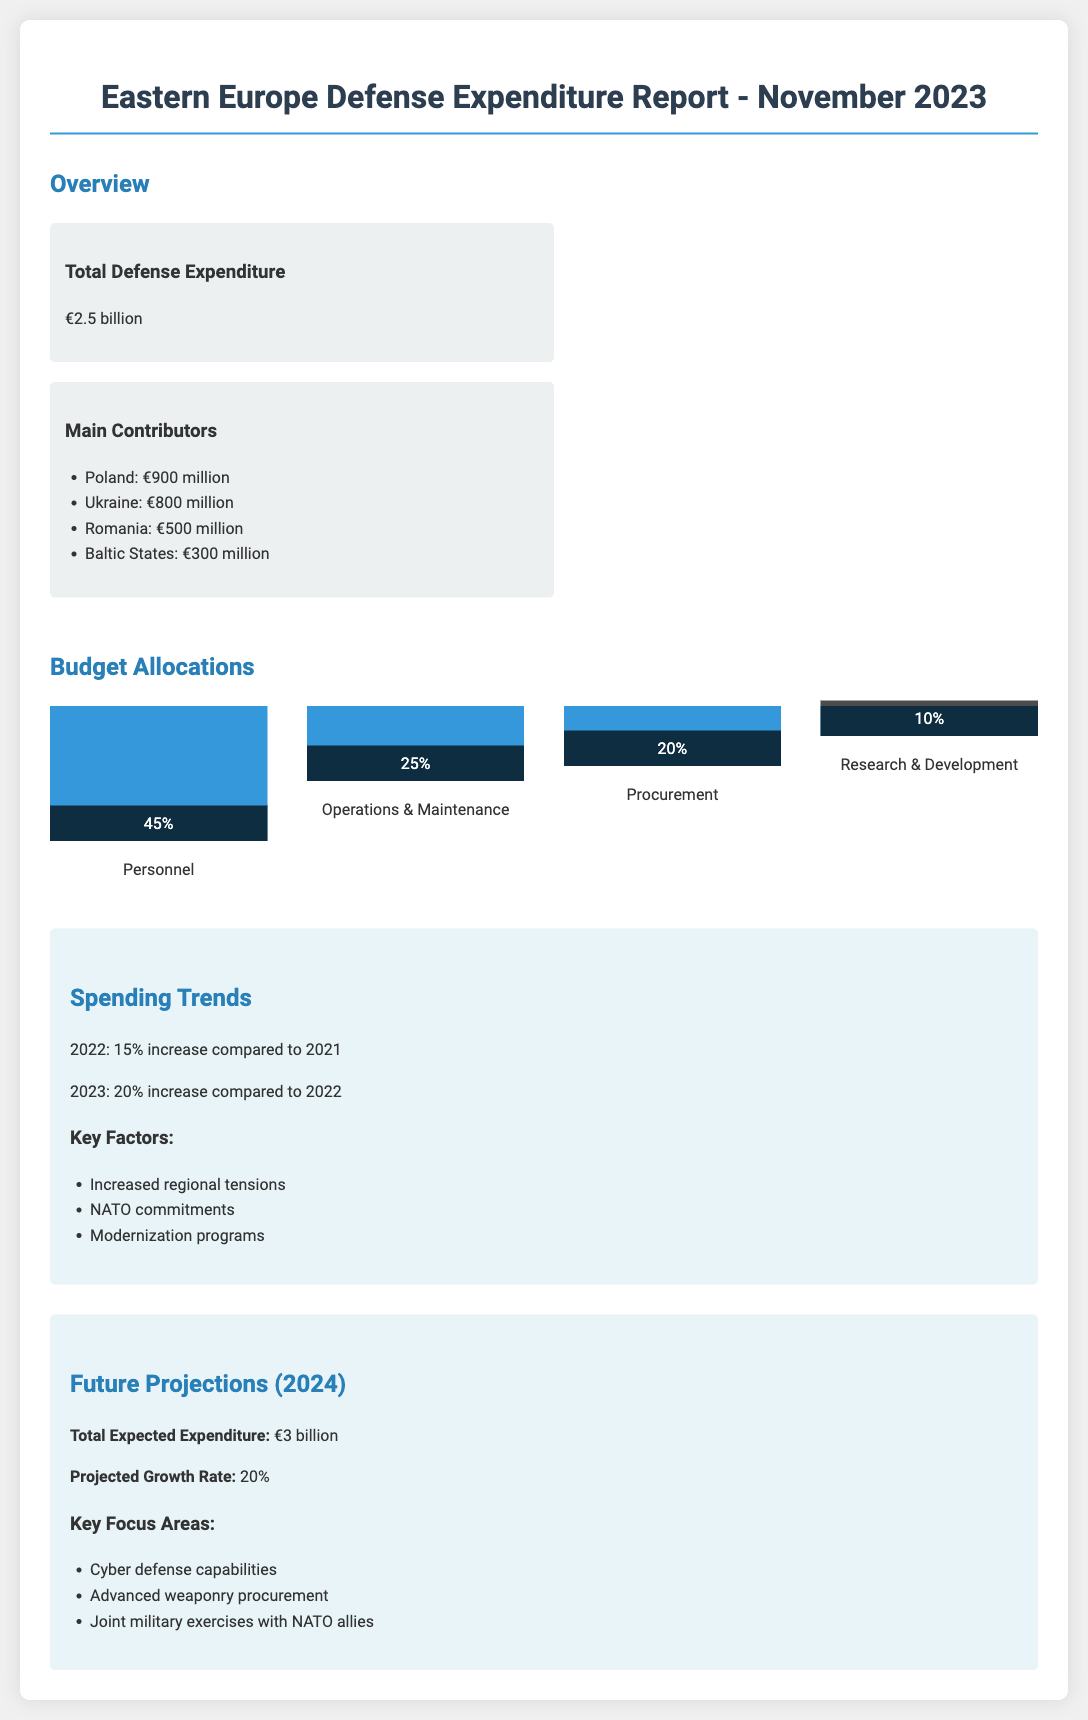What is the total defense expenditure? The total defense expenditure is presented in the overview section and is stated as €2.5 billion.
Answer: €2.5 billion Who are the main contributors to the defense expenditure? The main contributors listed in the document include Poland, Ukraine, Romania, and the Baltic States, with their respective amounts provided.
Answer: Poland, Ukraine, Romania, Baltic States What percentage of the budget is allocated to personnel? The budget allocation section shows that personnel accounts for 45% of the total budget.
Answer: 45% What is the projected total expected expenditure for 2024? The future projections indicate that the total expected expenditure for 2024 is €3 billion.
Answer: €3 billion What increase in defense expenditure was observed in 2022 compared to 2021? The spending trends show that there was a 15% increase in defense expenditure in 2022 compared to the previous year.
Answer: 15% What are the key focus areas for future defense spending? The key focus areas for 2024 are listed in the projections section, including cyber defense capabilities and advanced weaponry procurement.
Answer: Cyber defense capabilities, advanced weaponry procurement What is the projected growth rate for 2024? The document states that the projected growth rate for 2024 is 20%.
Answer: 20% What are some factors contributing to increased defense spending? The spending trends section highlights several key factors that contribute to increased spending, such as increased regional tensions and NATO commitments.
Answer: Increased regional tensions, NATO commitments 